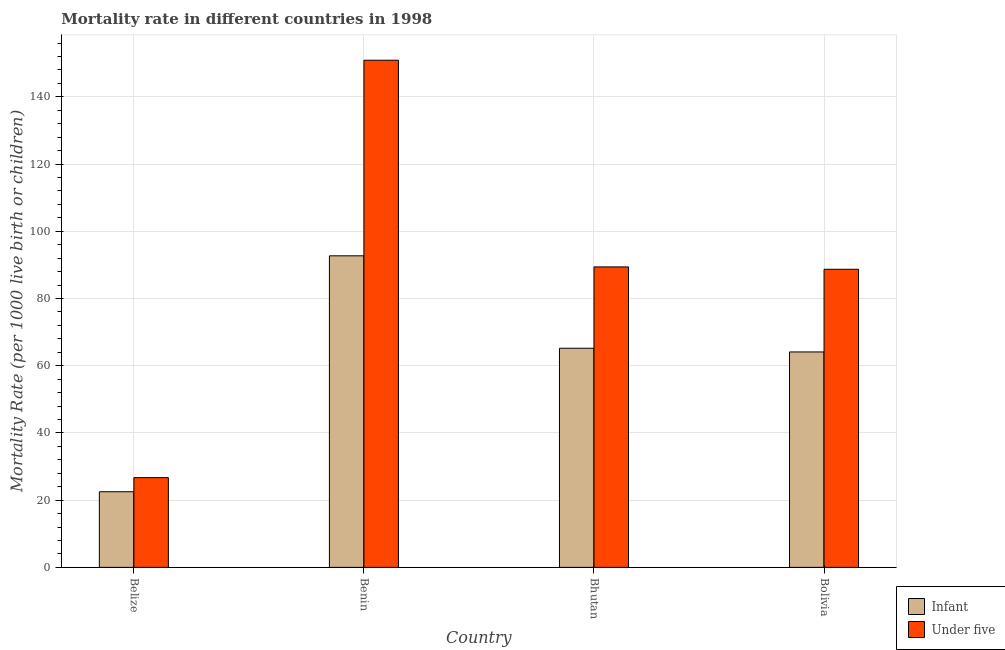How many different coloured bars are there?
Provide a short and direct response. 2. How many groups of bars are there?
Keep it short and to the point. 4. Are the number of bars per tick equal to the number of legend labels?
Your answer should be compact. Yes. Are the number of bars on each tick of the X-axis equal?
Provide a short and direct response. Yes. How many bars are there on the 4th tick from the left?
Ensure brevity in your answer.  2. How many bars are there on the 1st tick from the right?
Give a very brief answer. 2. What is the label of the 2nd group of bars from the left?
Provide a succinct answer. Benin. In how many cases, is the number of bars for a given country not equal to the number of legend labels?
Give a very brief answer. 0. What is the under-5 mortality rate in Bhutan?
Your response must be concise. 89.4. Across all countries, what is the maximum infant mortality rate?
Provide a succinct answer. 92.7. Across all countries, what is the minimum infant mortality rate?
Make the answer very short. 22.5. In which country was the infant mortality rate maximum?
Your answer should be very brief. Benin. In which country was the under-5 mortality rate minimum?
Offer a terse response. Belize. What is the total under-5 mortality rate in the graph?
Keep it short and to the point. 355.7. What is the difference between the under-5 mortality rate in Belize and that in Bolivia?
Make the answer very short. -62. What is the difference between the under-5 mortality rate in Benin and the infant mortality rate in Bhutan?
Your response must be concise. 85.7. What is the average infant mortality rate per country?
Provide a succinct answer. 61.12. What is the difference between the under-5 mortality rate and infant mortality rate in Bolivia?
Your answer should be very brief. 24.6. In how many countries, is the infant mortality rate greater than 52 ?
Your answer should be compact. 3. What is the ratio of the under-5 mortality rate in Belize to that in Bhutan?
Give a very brief answer. 0.3. Is the infant mortality rate in Belize less than that in Benin?
Keep it short and to the point. Yes. Is the difference between the under-5 mortality rate in Benin and Bhutan greater than the difference between the infant mortality rate in Benin and Bhutan?
Your response must be concise. Yes. What is the difference between the highest and the second highest under-5 mortality rate?
Provide a short and direct response. 61.5. What is the difference between the highest and the lowest infant mortality rate?
Keep it short and to the point. 70.2. What does the 2nd bar from the left in Belize represents?
Give a very brief answer. Under five. What does the 1st bar from the right in Bhutan represents?
Ensure brevity in your answer.  Under five. How many bars are there?
Offer a terse response. 8. How many countries are there in the graph?
Your response must be concise. 4. What is the difference between two consecutive major ticks on the Y-axis?
Your answer should be very brief. 20. Does the graph contain any zero values?
Make the answer very short. No. Where does the legend appear in the graph?
Offer a very short reply. Bottom right. What is the title of the graph?
Make the answer very short. Mortality rate in different countries in 1998. Does "US$" appear as one of the legend labels in the graph?
Provide a short and direct response. No. What is the label or title of the Y-axis?
Offer a very short reply. Mortality Rate (per 1000 live birth or children). What is the Mortality Rate (per 1000 live birth or children) in Under five in Belize?
Provide a short and direct response. 26.7. What is the Mortality Rate (per 1000 live birth or children) of Infant in Benin?
Provide a succinct answer. 92.7. What is the Mortality Rate (per 1000 live birth or children) of Under five in Benin?
Your response must be concise. 150.9. What is the Mortality Rate (per 1000 live birth or children) in Infant in Bhutan?
Provide a succinct answer. 65.2. What is the Mortality Rate (per 1000 live birth or children) of Under five in Bhutan?
Keep it short and to the point. 89.4. What is the Mortality Rate (per 1000 live birth or children) in Infant in Bolivia?
Keep it short and to the point. 64.1. What is the Mortality Rate (per 1000 live birth or children) in Under five in Bolivia?
Provide a short and direct response. 88.7. Across all countries, what is the maximum Mortality Rate (per 1000 live birth or children) in Infant?
Keep it short and to the point. 92.7. Across all countries, what is the maximum Mortality Rate (per 1000 live birth or children) of Under five?
Give a very brief answer. 150.9. Across all countries, what is the minimum Mortality Rate (per 1000 live birth or children) of Under five?
Give a very brief answer. 26.7. What is the total Mortality Rate (per 1000 live birth or children) of Infant in the graph?
Your answer should be very brief. 244.5. What is the total Mortality Rate (per 1000 live birth or children) in Under five in the graph?
Ensure brevity in your answer.  355.7. What is the difference between the Mortality Rate (per 1000 live birth or children) of Infant in Belize and that in Benin?
Your answer should be very brief. -70.2. What is the difference between the Mortality Rate (per 1000 live birth or children) in Under five in Belize and that in Benin?
Give a very brief answer. -124.2. What is the difference between the Mortality Rate (per 1000 live birth or children) of Infant in Belize and that in Bhutan?
Provide a succinct answer. -42.7. What is the difference between the Mortality Rate (per 1000 live birth or children) of Under five in Belize and that in Bhutan?
Your response must be concise. -62.7. What is the difference between the Mortality Rate (per 1000 live birth or children) in Infant in Belize and that in Bolivia?
Keep it short and to the point. -41.6. What is the difference between the Mortality Rate (per 1000 live birth or children) of Under five in Belize and that in Bolivia?
Provide a succinct answer. -62. What is the difference between the Mortality Rate (per 1000 live birth or children) in Infant in Benin and that in Bhutan?
Make the answer very short. 27.5. What is the difference between the Mortality Rate (per 1000 live birth or children) in Under five in Benin and that in Bhutan?
Your response must be concise. 61.5. What is the difference between the Mortality Rate (per 1000 live birth or children) of Infant in Benin and that in Bolivia?
Keep it short and to the point. 28.6. What is the difference between the Mortality Rate (per 1000 live birth or children) in Under five in Benin and that in Bolivia?
Provide a succinct answer. 62.2. What is the difference between the Mortality Rate (per 1000 live birth or children) of Infant in Bhutan and that in Bolivia?
Your response must be concise. 1.1. What is the difference between the Mortality Rate (per 1000 live birth or children) in Under five in Bhutan and that in Bolivia?
Your answer should be compact. 0.7. What is the difference between the Mortality Rate (per 1000 live birth or children) of Infant in Belize and the Mortality Rate (per 1000 live birth or children) of Under five in Benin?
Your response must be concise. -128.4. What is the difference between the Mortality Rate (per 1000 live birth or children) in Infant in Belize and the Mortality Rate (per 1000 live birth or children) in Under five in Bhutan?
Offer a very short reply. -66.9. What is the difference between the Mortality Rate (per 1000 live birth or children) in Infant in Belize and the Mortality Rate (per 1000 live birth or children) in Under five in Bolivia?
Your response must be concise. -66.2. What is the difference between the Mortality Rate (per 1000 live birth or children) of Infant in Benin and the Mortality Rate (per 1000 live birth or children) of Under five in Bhutan?
Your response must be concise. 3.3. What is the difference between the Mortality Rate (per 1000 live birth or children) of Infant in Bhutan and the Mortality Rate (per 1000 live birth or children) of Under five in Bolivia?
Give a very brief answer. -23.5. What is the average Mortality Rate (per 1000 live birth or children) in Infant per country?
Ensure brevity in your answer.  61.12. What is the average Mortality Rate (per 1000 live birth or children) of Under five per country?
Provide a succinct answer. 88.92. What is the difference between the Mortality Rate (per 1000 live birth or children) in Infant and Mortality Rate (per 1000 live birth or children) in Under five in Benin?
Your answer should be compact. -58.2. What is the difference between the Mortality Rate (per 1000 live birth or children) in Infant and Mortality Rate (per 1000 live birth or children) in Under five in Bhutan?
Provide a short and direct response. -24.2. What is the difference between the Mortality Rate (per 1000 live birth or children) in Infant and Mortality Rate (per 1000 live birth or children) in Under five in Bolivia?
Make the answer very short. -24.6. What is the ratio of the Mortality Rate (per 1000 live birth or children) in Infant in Belize to that in Benin?
Ensure brevity in your answer.  0.24. What is the ratio of the Mortality Rate (per 1000 live birth or children) in Under five in Belize to that in Benin?
Make the answer very short. 0.18. What is the ratio of the Mortality Rate (per 1000 live birth or children) in Infant in Belize to that in Bhutan?
Your response must be concise. 0.35. What is the ratio of the Mortality Rate (per 1000 live birth or children) of Under five in Belize to that in Bhutan?
Your answer should be very brief. 0.3. What is the ratio of the Mortality Rate (per 1000 live birth or children) of Infant in Belize to that in Bolivia?
Provide a succinct answer. 0.35. What is the ratio of the Mortality Rate (per 1000 live birth or children) of Under five in Belize to that in Bolivia?
Provide a short and direct response. 0.3. What is the ratio of the Mortality Rate (per 1000 live birth or children) of Infant in Benin to that in Bhutan?
Make the answer very short. 1.42. What is the ratio of the Mortality Rate (per 1000 live birth or children) of Under five in Benin to that in Bhutan?
Your response must be concise. 1.69. What is the ratio of the Mortality Rate (per 1000 live birth or children) in Infant in Benin to that in Bolivia?
Make the answer very short. 1.45. What is the ratio of the Mortality Rate (per 1000 live birth or children) in Under five in Benin to that in Bolivia?
Keep it short and to the point. 1.7. What is the ratio of the Mortality Rate (per 1000 live birth or children) in Infant in Bhutan to that in Bolivia?
Keep it short and to the point. 1.02. What is the ratio of the Mortality Rate (per 1000 live birth or children) in Under five in Bhutan to that in Bolivia?
Offer a very short reply. 1.01. What is the difference between the highest and the second highest Mortality Rate (per 1000 live birth or children) of Infant?
Offer a very short reply. 27.5. What is the difference between the highest and the second highest Mortality Rate (per 1000 live birth or children) in Under five?
Offer a very short reply. 61.5. What is the difference between the highest and the lowest Mortality Rate (per 1000 live birth or children) of Infant?
Make the answer very short. 70.2. What is the difference between the highest and the lowest Mortality Rate (per 1000 live birth or children) in Under five?
Your answer should be very brief. 124.2. 